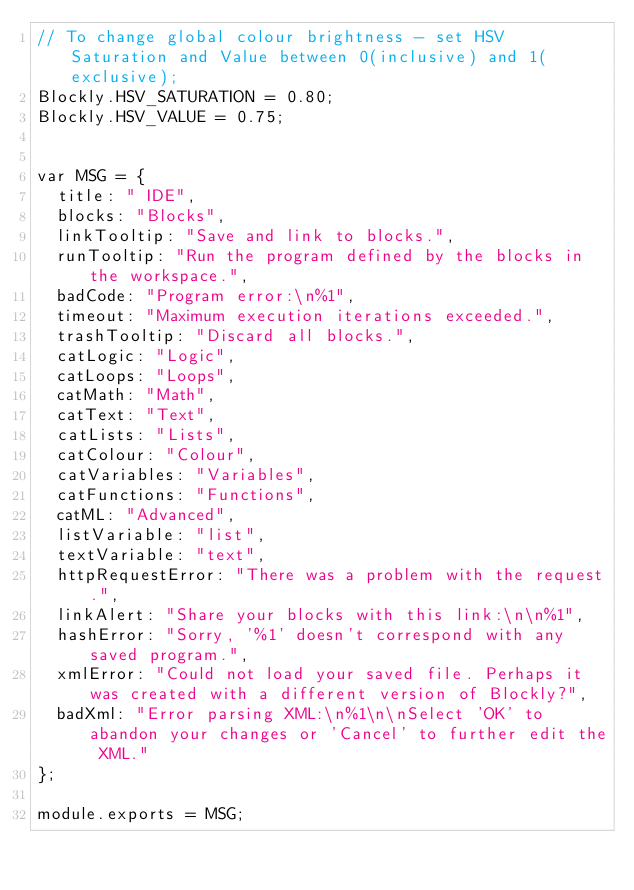<code> <loc_0><loc_0><loc_500><loc_500><_JavaScript_>// To change global colour brightness - set HSV Saturation and Value between 0(inclusive) and 1(exclusive);
Blockly.HSV_SATURATION = 0.80;
Blockly.HSV_VALUE = 0.75;


var MSG = {
  title: " IDE",
  blocks: "Blocks",
  linkTooltip: "Save and link to blocks.",
  runTooltip: "Run the program defined by the blocks in the workspace.",
  badCode: "Program error:\n%1",
  timeout: "Maximum execution iterations exceeded.",
  trashTooltip: "Discard all blocks.",
  catLogic: "Logic",
  catLoops: "Loops",
  catMath: "Math",
  catText: "Text",
  catLists: "Lists",
  catColour: "Colour",
  catVariables: "Variables",
  catFunctions: "Functions",
  catML: "Advanced",
  listVariable: "list",
  textVariable: "text",
  httpRequestError: "There was a problem with the request.",
  linkAlert: "Share your blocks with this link:\n\n%1",
  hashError: "Sorry, '%1' doesn't correspond with any saved program.",
  xmlError: "Could not load your saved file. Perhaps it was created with a different version of Blockly?",
  badXml: "Error parsing XML:\n%1\n\nSelect 'OK' to abandon your changes or 'Cancel' to further edit the XML."
};

module.exports = MSG;</code> 